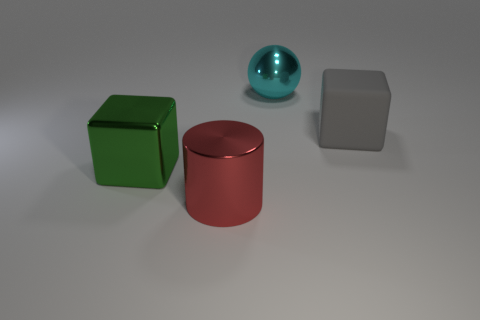There is a cube that is on the left side of the big metallic ball; what is its material?
Your response must be concise. Metal. Is the number of spheres less than the number of cyan shiny blocks?
Ensure brevity in your answer.  No. There is a thing that is both to the right of the big red metal thing and on the left side of the gray block; how big is it?
Provide a short and direct response. Large. There is a thing that is in front of the big block in front of the big object that is right of the cyan ball; what is its size?
Ensure brevity in your answer.  Large. There is a large metallic thing that is in front of the large green shiny object; does it have the same color as the matte thing?
Your answer should be very brief. No. What number of things are big red objects or metal spheres?
Keep it short and to the point. 2. The matte cube that is behind the green metal cube is what color?
Keep it short and to the point. Gray. Is the number of big matte blocks in front of the large red shiny thing less than the number of purple matte spheres?
Provide a short and direct response. No. Is there any other thing that has the same size as the green object?
Provide a short and direct response. Yes. Is the material of the big gray object the same as the red cylinder?
Provide a succinct answer. No. 